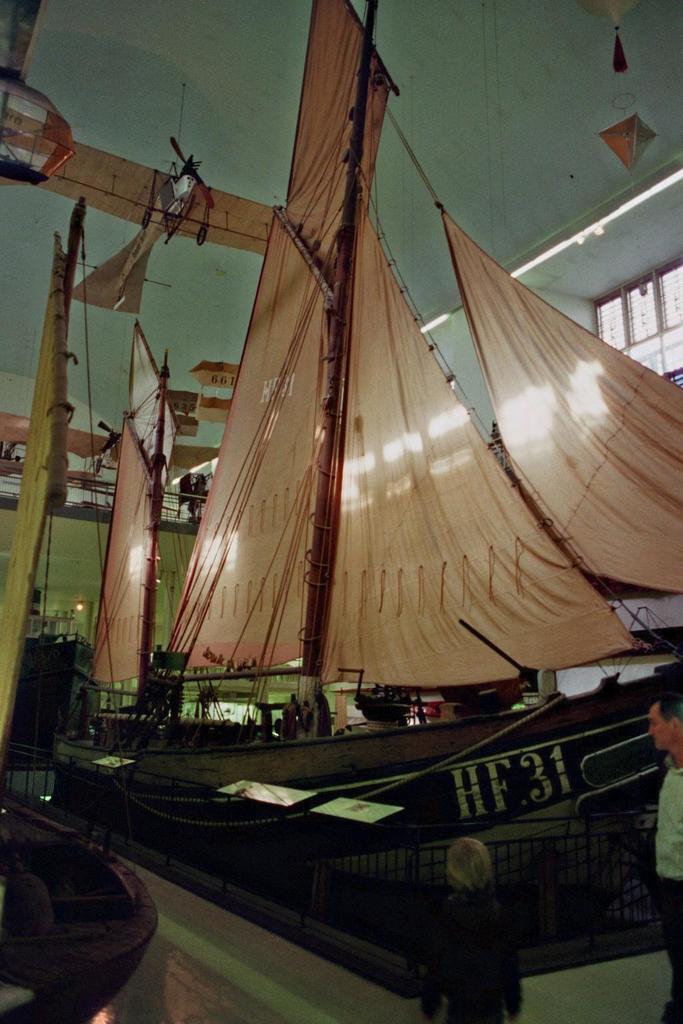In one or two sentences, can you explain what this image depicts? In this image in front there are people. There is a metal fence. There are boats. On the top of the image there are lights. 